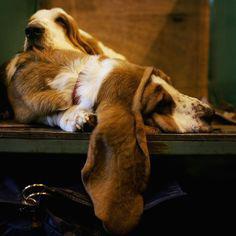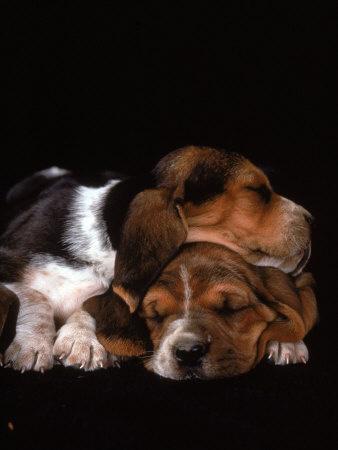The first image is the image on the left, the second image is the image on the right. Given the left and right images, does the statement "A basset hound is sleeping on a platform facing the right, with one ear hanging down." hold true? Answer yes or no. Yes. 